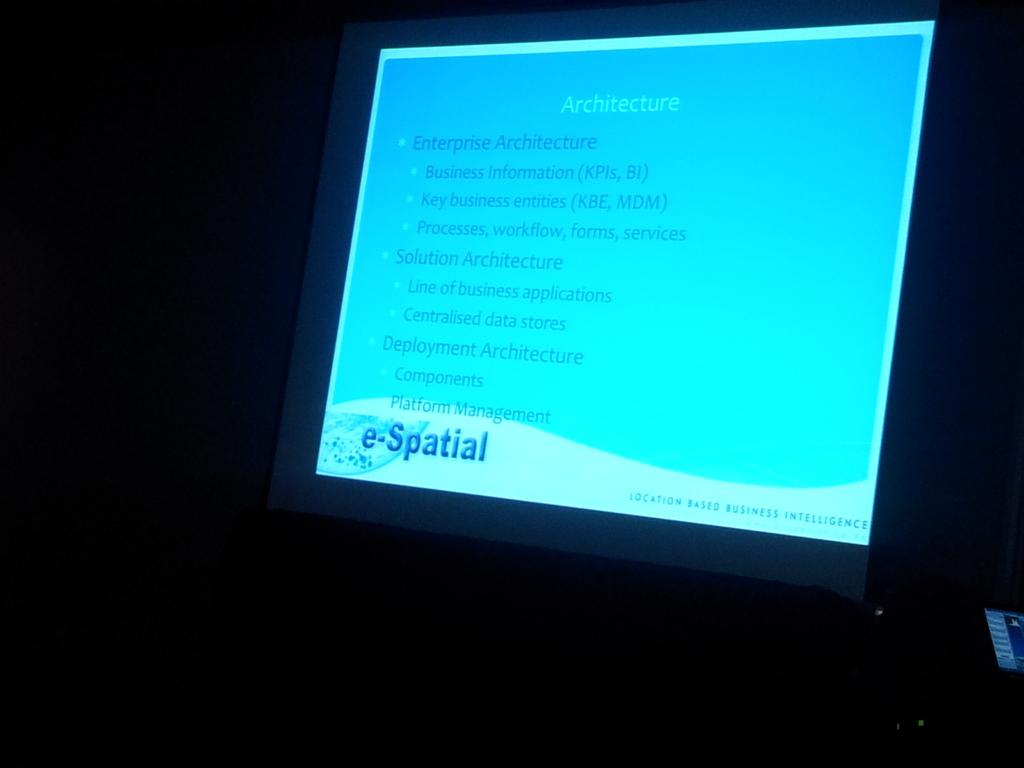<image>
Give a short and clear explanation of the subsequent image. A presentation on a brightly lit screen that is about architecture. 